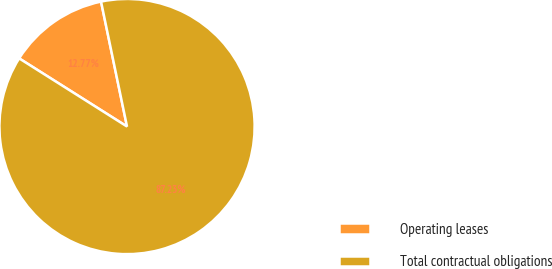Convert chart. <chart><loc_0><loc_0><loc_500><loc_500><pie_chart><fcel>Operating leases<fcel>Total contractual obligations<nl><fcel>12.77%<fcel>87.23%<nl></chart> 